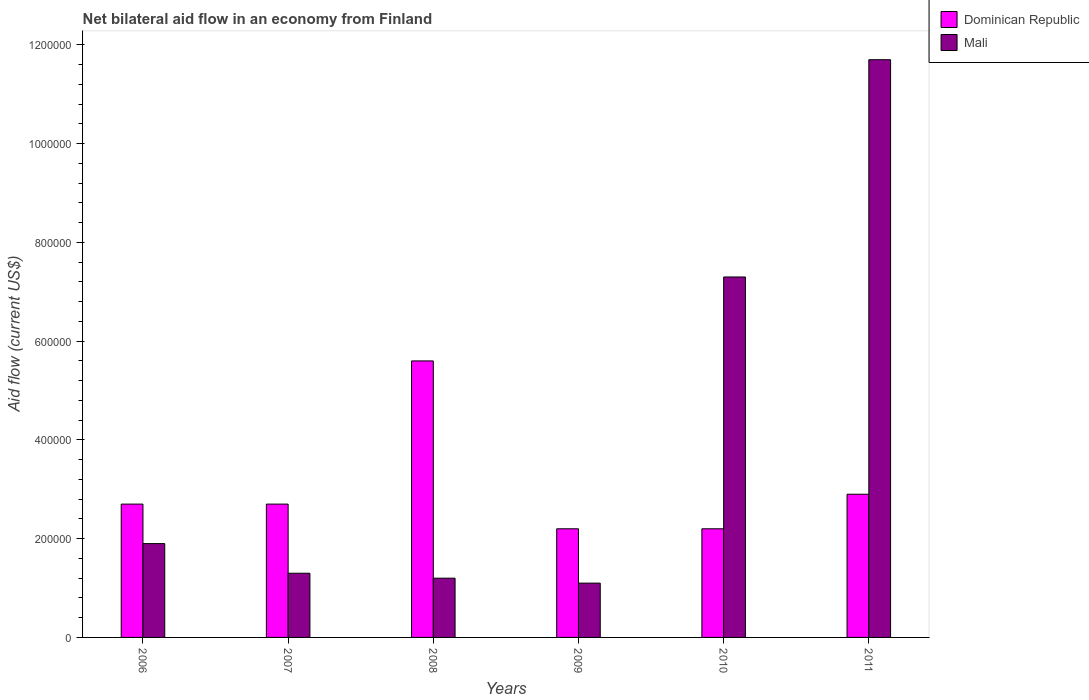How many different coloured bars are there?
Your answer should be compact. 2. In how many cases, is the number of bars for a given year not equal to the number of legend labels?
Provide a succinct answer. 0. Across all years, what is the maximum net bilateral aid flow in Dominican Republic?
Keep it short and to the point. 5.60e+05. In which year was the net bilateral aid flow in Mali maximum?
Keep it short and to the point. 2011. In which year was the net bilateral aid flow in Mali minimum?
Ensure brevity in your answer.  2009. What is the total net bilateral aid flow in Mali in the graph?
Make the answer very short. 2.45e+06. What is the difference between the net bilateral aid flow in Dominican Republic in 2009 and that in 2011?
Ensure brevity in your answer.  -7.00e+04. What is the average net bilateral aid flow in Mali per year?
Your answer should be compact. 4.08e+05. In the year 2006, what is the difference between the net bilateral aid flow in Dominican Republic and net bilateral aid flow in Mali?
Make the answer very short. 8.00e+04. In how many years, is the net bilateral aid flow in Dominican Republic greater than 1120000 US$?
Your response must be concise. 0. What is the ratio of the net bilateral aid flow in Dominican Republic in 2008 to that in 2009?
Provide a succinct answer. 2.55. What is the difference between the highest and the lowest net bilateral aid flow in Mali?
Your answer should be compact. 1.06e+06. Is the sum of the net bilateral aid flow in Dominican Republic in 2008 and 2009 greater than the maximum net bilateral aid flow in Mali across all years?
Your response must be concise. No. What does the 1st bar from the left in 2009 represents?
Offer a very short reply. Dominican Republic. What does the 2nd bar from the right in 2009 represents?
Give a very brief answer. Dominican Republic. Are all the bars in the graph horizontal?
Make the answer very short. No. How many years are there in the graph?
Ensure brevity in your answer.  6. Are the values on the major ticks of Y-axis written in scientific E-notation?
Provide a succinct answer. No. How many legend labels are there?
Your answer should be compact. 2. What is the title of the graph?
Make the answer very short. Net bilateral aid flow in an economy from Finland. Does "United Arab Emirates" appear as one of the legend labels in the graph?
Your answer should be compact. No. What is the label or title of the X-axis?
Keep it short and to the point. Years. What is the Aid flow (current US$) in Dominican Republic in 2006?
Offer a terse response. 2.70e+05. What is the Aid flow (current US$) in Mali in 2006?
Offer a very short reply. 1.90e+05. What is the Aid flow (current US$) of Mali in 2007?
Offer a very short reply. 1.30e+05. What is the Aid flow (current US$) of Dominican Republic in 2008?
Provide a succinct answer. 5.60e+05. What is the Aid flow (current US$) of Dominican Republic in 2010?
Provide a short and direct response. 2.20e+05. What is the Aid flow (current US$) of Mali in 2010?
Keep it short and to the point. 7.30e+05. What is the Aid flow (current US$) of Dominican Republic in 2011?
Keep it short and to the point. 2.90e+05. What is the Aid flow (current US$) in Mali in 2011?
Offer a terse response. 1.17e+06. Across all years, what is the maximum Aid flow (current US$) in Dominican Republic?
Offer a terse response. 5.60e+05. Across all years, what is the maximum Aid flow (current US$) in Mali?
Make the answer very short. 1.17e+06. Across all years, what is the minimum Aid flow (current US$) of Mali?
Your answer should be very brief. 1.10e+05. What is the total Aid flow (current US$) of Dominican Republic in the graph?
Your response must be concise. 1.83e+06. What is the total Aid flow (current US$) of Mali in the graph?
Offer a very short reply. 2.45e+06. What is the difference between the Aid flow (current US$) of Dominican Republic in 2006 and that in 2007?
Offer a very short reply. 0. What is the difference between the Aid flow (current US$) of Mali in 2006 and that in 2008?
Provide a succinct answer. 7.00e+04. What is the difference between the Aid flow (current US$) in Mali in 2006 and that in 2009?
Ensure brevity in your answer.  8.00e+04. What is the difference between the Aid flow (current US$) of Mali in 2006 and that in 2010?
Your answer should be compact. -5.40e+05. What is the difference between the Aid flow (current US$) of Mali in 2006 and that in 2011?
Your answer should be very brief. -9.80e+05. What is the difference between the Aid flow (current US$) of Mali in 2007 and that in 2010?
Offer a terse response. -6.00e+05. What is the difference between the Aid flow (current US$) in Dominican Republic in 2007 and that in 2011?
Your response must be concise. -2.00e+04. What is the difference between the Aid flow (current US$) in Mali in 2007 and that in 2011?
Provide a succinct answer. -1.04e+06. What is the difference between the Aid flow (current US$) in Dominican Republic in 2008 and that in 2010?
Your answer should be compact. 3.40e+05. What is the difference between the Aid flow (current US$) in Mali in 2008 and that in 2010?
Offer a very short reply. -6.10e+05. What is the difference between the Aid flow (current US$) of Dominican Republic in 2008 and that in 2011?
Give a very brief answer. 2.70e+05. What is the difference between the Aid flow (current US$) of Mali in 2008 and that in 2011?
Provide a succinct answer. -1.05e+06. What is the difference between the Aid flow (current US$) of Dominican Republic in 2009 and that in 2010?
Make the answer very short. 0. What is the difference between the Aid flow (current US$) in Mali in 2009 and that in 2010?
Offer a very short reply. -6.20e+05. What is the difference between the Aid flow (current US$) of Dominican Republic in 2009 and that in 2011?
Offer a very short reply. -7.00e+04. What is the difference between the Aid flow (current US$) of Mali in 2009 and that in 2011?
Keep it short and to the point. -1.06e+06. What is the difference between the Aid flow (current US$) of Dominican Republic in 2010 and that in 2011?
Your answer should be compact. -7.00e+04. What is the difference between the Aid flow (current US$) in Mali in 2010 and that in 2011?
Give a very brief answer. -4.40e+05. What is the difference between the Aid flow (current US$) in Dominican Republic in 2006 and the Aid flow (current US$) in Mali in 2009?
Your answer should be compact. 1.60e+05. What is the difference between the Aid flow (current US$) of Dominican Republic in 2006 and the Aid flow (current US$) of Mali in 2010?
Your answer should be compact. -4.60e+05. What is the difference between the Aid flow (current US$) in Dominican Republic in 2006 and the Aid flow (current US$) in Mali in 2011?
Give a very brief answer. -9.00e+05. What is the difference between the Aid flow (current US$) of Dominican Republic in 2007 and the Aid flow (current US$) of Mali in 2010?
Make the answer very short. -4.60e+05. What is the difference between the Aid flow (current US$) in Dominican Republic in 2007 and the Aid flow (current US$) in Mali in 2011?
Ensure brevity in your answer.  -9.00e+05. What is the difference between the Aid flow (current US$) of Dominican Republic in 2008 and the Aid flow (current US$) of Mali in 2009?
Keep it short and to the point. 4.50e+05. What is the difference between the Aid flow (current US$) of Dominican Republic in 2008 and the Aid flow (current US$) of Mali in 2011?
Your answer should be very brief. -6.10e+05. What is the difference between the Aid flow (current US$) in Dominican Republic in 2009 and the Aid flow (current US$) in Mali in 2010?
Offer a very short reply. -5.10e+05. What is the difference between the Aid flow (current US$) in Dominican Republic in 2009 and the Aid flow (current US$) in Mali in 2011?
Your response must be concise. -9.50e+05. What is the difference between the Aid flow (current US$) of Dominican Republic in 2010 and the Aid flow (current US$) of Mali in 2011?
Provide a short and direct response. -9.50e+05. What is the average Aid flow (current US$) of Dominican Republic per year?
Ensure brevity in your answer.  3.05e+05. What is the average Aid flow (current US$) of Mali per year?
Offer a very short reply. 4.08e+05. In the year 2006, what is the difference between the Aid flow (current US$) of Dominican Republic and Aid flow (current US$) of Mali?
Offer a very short reply. 8.00e+04. In the year 2007, what is the difference between the Aid flow (current US$) of Dominican Republic and Aid flow (current US$) of Mali?
Keep it short and to the point. 1.40e+05. In the year 2008, what is the difference between the Aid flow (current US$) of Dominican Republic and Aid flow (current US$) of Mali?
Your answer should be compact. 4.40e+05. In the year 2010, what is the difference between the Aid flow (current US$) in Dominican Republic and Aid flow (current US$) in Mali?
Your response must be concise. -5.10e+05. In the year 2011, what is the difference between the Aid flow (current US$) in Dominican Republic and Aid flow (current US$) in Mali?
Make the answer very short. -8.80e+05. What is the ratio of the Aid flow (current US$) of Mali in 2006 to that in 2007?
Provide a short and direct response. 1.46. What is the ratio of the Aid flow (current US$) of Dominican Republic in 2006 to that in 2008?
Your answer should be very brief. 0.48. What is the ratio of the Aid flow (current US$) in Mali in 2006 to that in 2008?
Provide a succinct answer. 1.58. What is the ratio of the Aid flow (current US$) of Dominican Republic in 2006 to that in 2009?
Your answer should be very brief. 1.23. What is the ratio of the Aid flow (current US$) of Mali in 2006 to that in 2009?
Keep it short and to the point. 1.73. What is the ratio of the Aid flow (current US$) of Dominican Republic in 2006 to that in 2010?
Ensure brevity in your answer.  1.23. What is the ratio of the Aid flow (current US$) of Mali in 2006 to that in 2010?
Give a very brief answer. 0.26. What is the ratio of the Aid flow (current US$) in Mali in 2006 to that in 2011?
Your answer should be compact. 0.16. What is the ratio of the Aid flow (current US$) in Dominican Republic in 2007 to that in 2008?
Provide a succinct answer. 0.48. What is the ratio of the Aid flow (current US$) of Mali in 2007 to that in 2008?
Provide a short and direct response. 1.08. What is the ratio of the Aid flow (current US$) in Dominican Republic in 2007 to that in 2009?
Your answer should be very brief. 1.23. What is the ratio of the Aid flow (current US$) in Mali in 2007 to that in 2009?
Ensure brevity in your answer.  1.18. What is the ratio of the Aid flow (current US$) in Dominican Republic in 2007 to that in 2010?
Offer a terse response. 1.23. What is the ratio of the Aid flow (current US$) of Mali in 2007 to that in 2010?
Provide a succinct answer. 0.18. What is the ratio of the Aid flow (current US$) in Dominican Republic in 2008 to that in 2009?
Your answer should be compact. 2.55. What is the ratio of the Aid flow (current US$) of Mali in 2008 to that in 2009?
Offer a very short reply. 1.09. What is the ratio of the Aid flow (current US$) in Dominican Republic in 2008 to that in 2010?
Ensure brevity in your answer.  2.55. What is the ratio of the Aid flow (current US$) in Mali in 2008 to that in 2010?
Provide a short and direct response. 0.16. What is the ratio of the Aid flow (current US$) of Dominican Republic in 2008 to that in 2011?
Your answer should be compact. 1.93. What is the ratio of the Aid flow (current US$) of Mali in 2008 to that in 2011?
Offer a very short reply. 0.1. What is the ratio of the Aid flow (current US$) in Dominican Republic in 2009 to that in 2010?
Your answer should be compact. 1. What is the ratio of the Aid flow (current US$) of Mali in 2009 to that in 2010?
Provide a succinct answer. 0.15. What is the ratio of the Aid flow (current US$) in Dominican Republic in 2009 to that in 2011?
Your answer should be very brief. 0.76. What is the ratio of the Aid flow (current US$) in Mali in 2009 to that in 2011?
Your answer should be very brief. 0.09. What is the ratio of the Aid flow (current US$) of Dominican Republic in 2010 to that in 2011?
Your response must be concise. 0.76. What is the ratio of the Aid flow (current US$) in Mali in 2010 to that in 2011?
Give a very brief answer. 0.62. What is the difference between the highest and the second highest Aid flow (current US$) in Dominican Republic?
Offer a terse response. 2.70e+05. What is the difference between the highest and the lowest Aid flow (current US$) of Dominican Republic?
Provide a short and direct response. 3.40e+05. What is the difference between the highest and the lowest Aid flow (current US$) of Mali?
Offer a very short reply. 1.06e+06. 